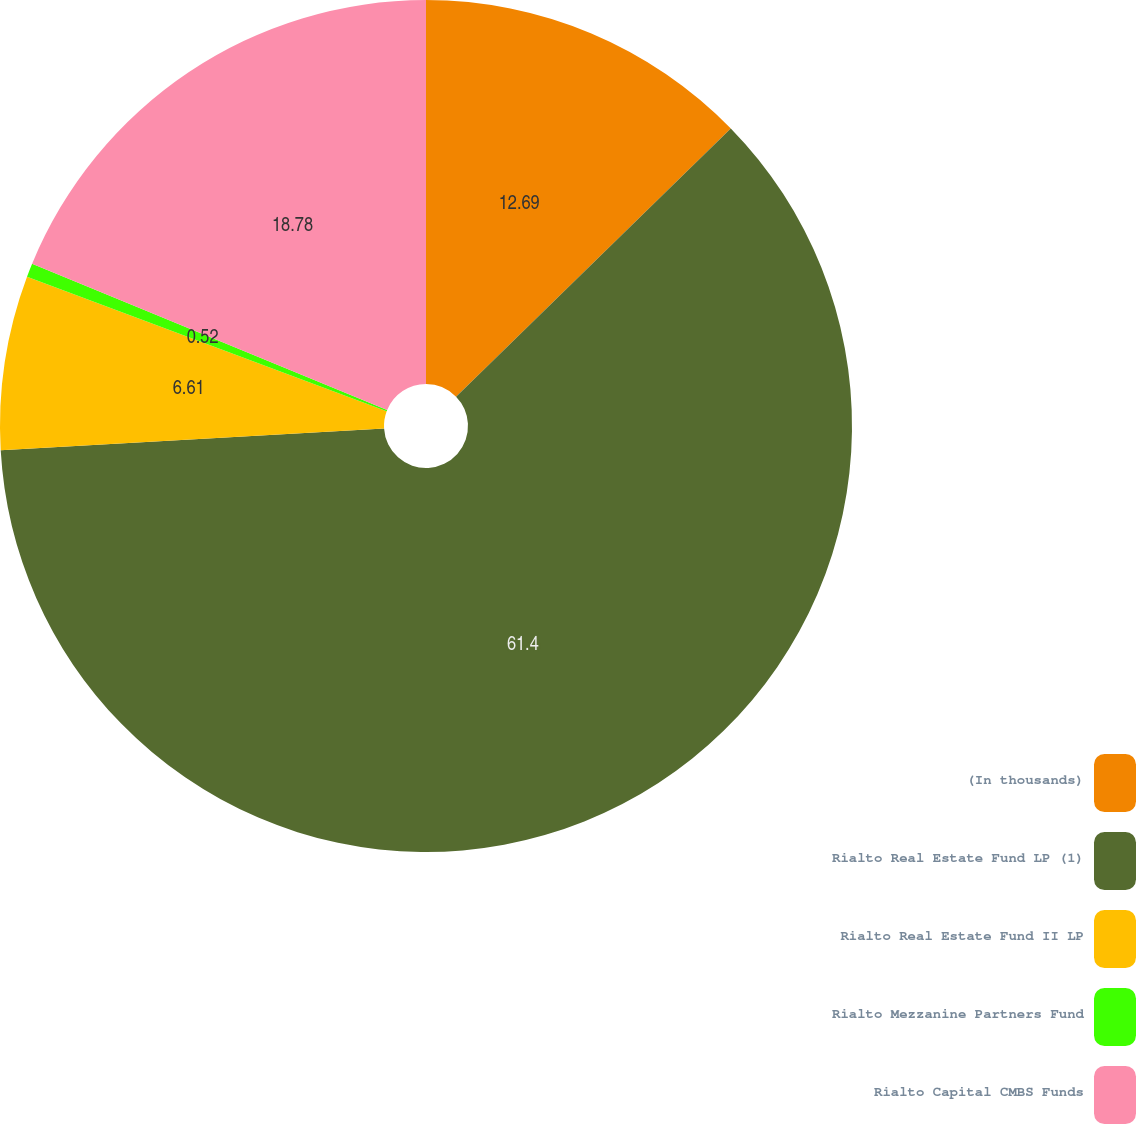Convert chart to OTSL. <chart><loc_0><loc_0><loc_500><loc_500><pie_chart><fcel>(In thousands)<fcel>Rialto Real Estate Fund LP (1)<fcel>Rialto Real Estate Fund II LP<fcel>Rialto Mezzanine Partners Fund<fcel>Rialto Capital CMBS Funds<nl><fcel>12.69%<fcel>61.4%<fcel>6.61%<fcel>0.52%<fcel>18.78%<nl></chart> 